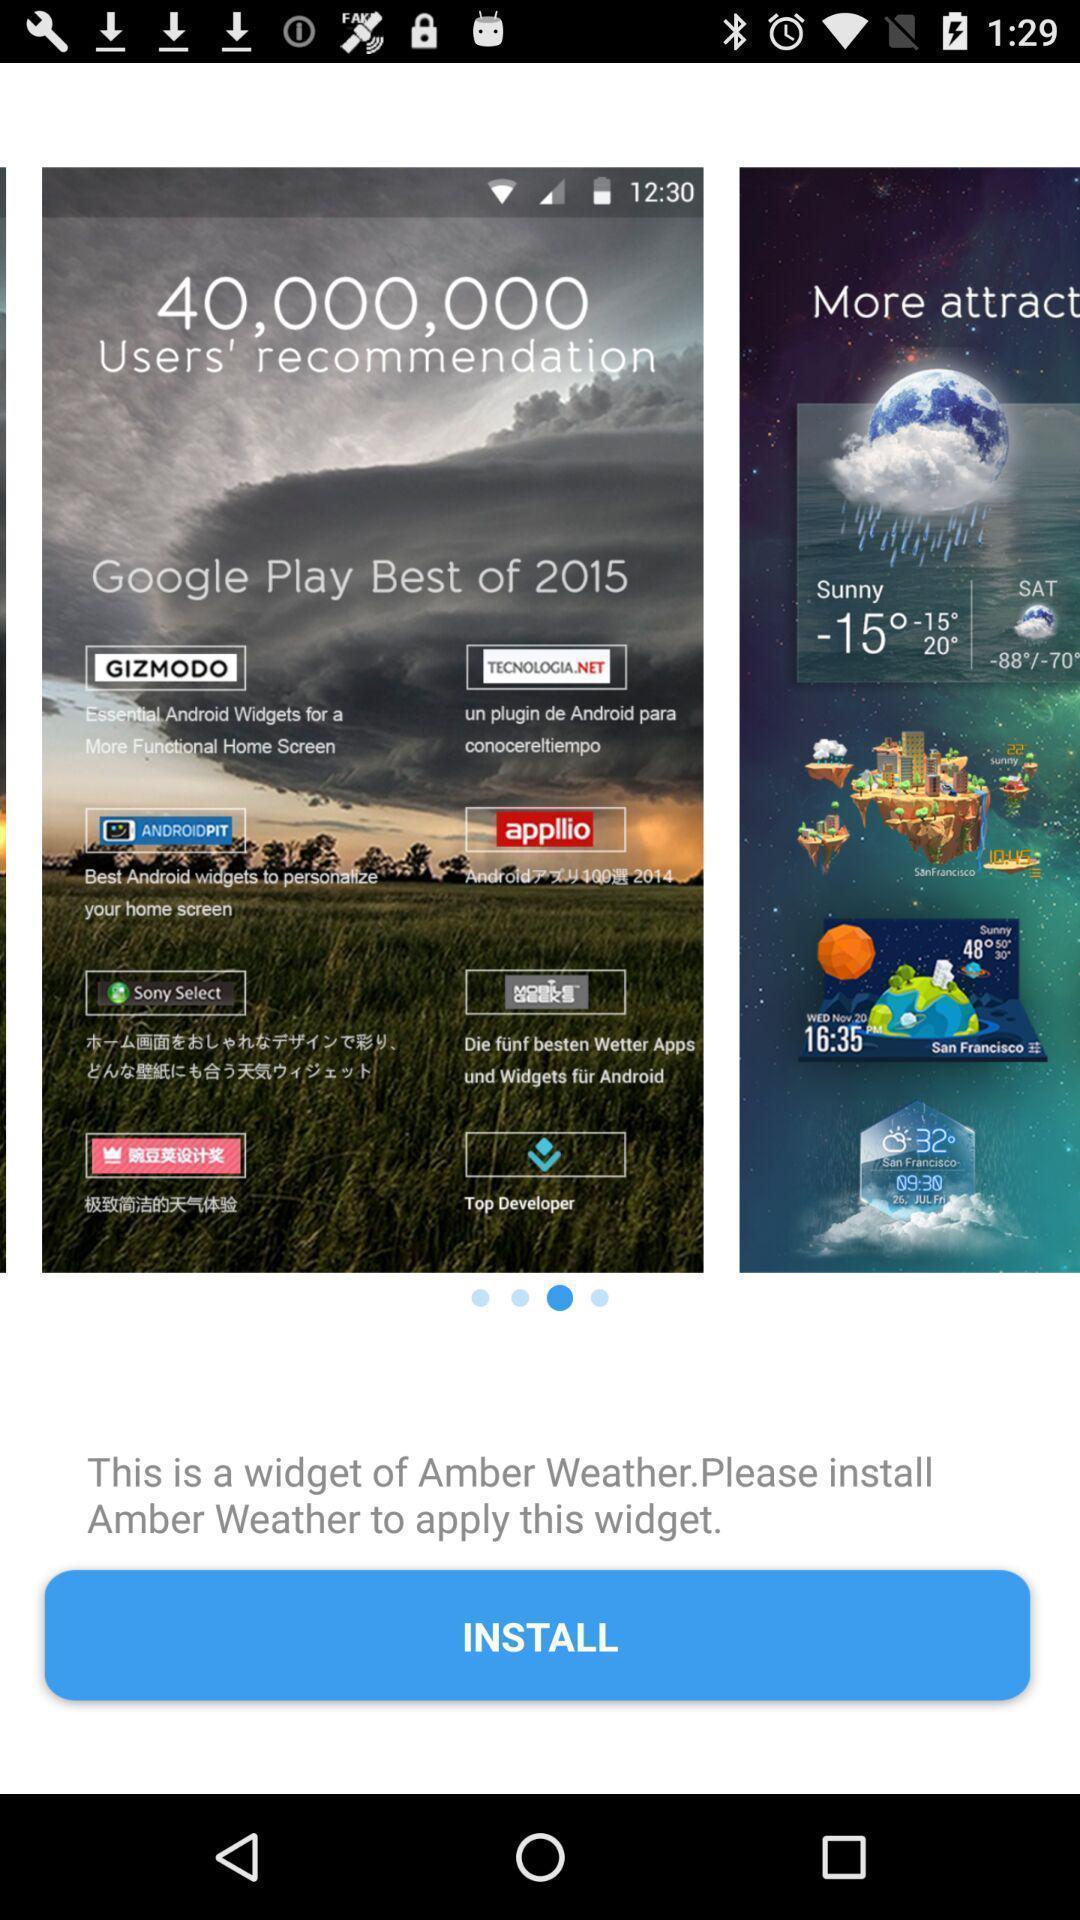Give me a summary of this screen capture. Page showing various slides on weather app. 